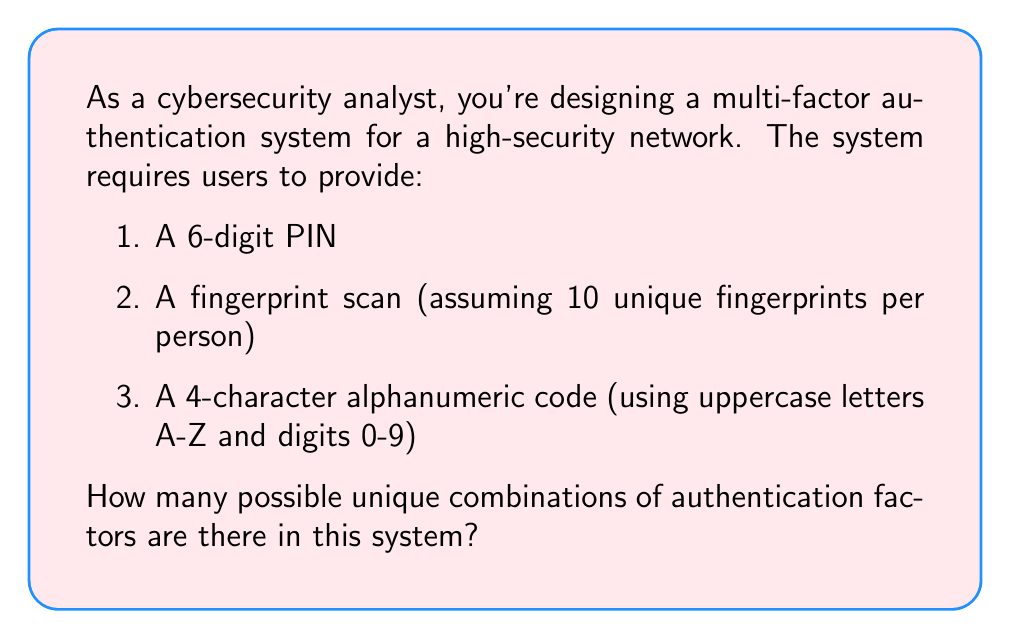Can you solve this math problem? Let's break this down step-by-step:

1. 6-digit PIN:
   - Each digit can be any number from 0 to 9
   - Total possibilities = $10^6$

2. Fingerprint scan:
   - Assuming 10 unique fingerprints per person
   - Total possibilities = 10

3. 4-character alphanumeric code:
   - Each character can be any of 26 uppercase letters or 10 digits
   - Total possibilities for each character = 36
   - For 4 characters, total possibilities = $36^4$

Now, we apply the multiplication principle. Since each factor is independent, we multiply the number of possibilities for each factor:

$$ \text{Total combinations} = 10^6 \times 10 \times 36^4 $$

Calculating this:
$$ \begin{align}
\text{Total combinations} &= 1,000,000 \times 10 \times 1,679,616 \\
&= 10,000,000 \times 1,679,616 \\
&= 16,796,160,000,000
\end{align} $$

This equals approximately $1.68 \times 10^{13}$ possible unique combinations.
Answer: $1.68 \times 10^{13}$ 